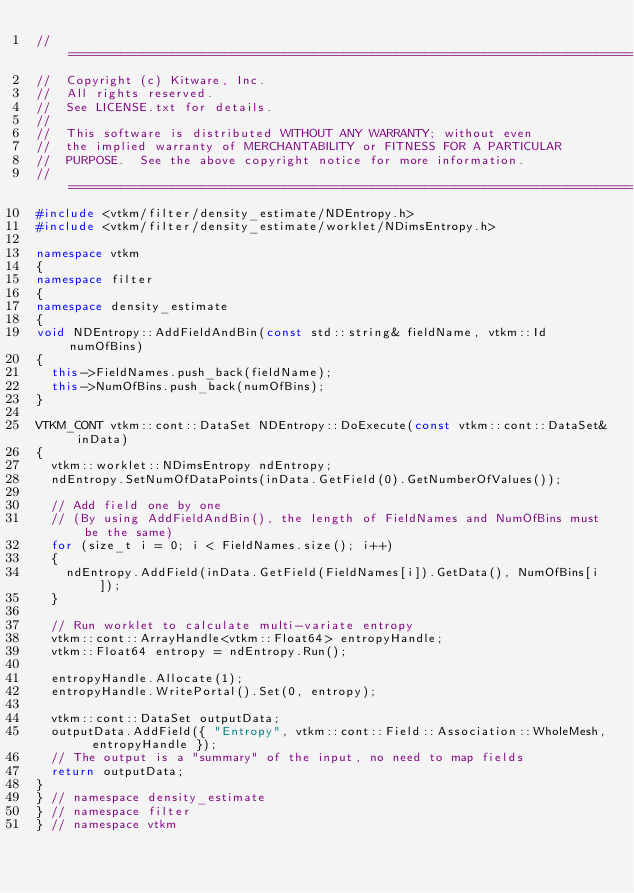Convert code to text. <code><loc_0><loc_0><loc_500><loc_500><_C++_>//============================================================================
//  Copyright (c) Kitware, Inc.
//  All rights reserved.
//  See LICENSE.txt for details.
//
//  This software is distributed WITHOUT ANY WARRANTY; without even
//  the implied warranty of MERCHANTABILITY or FITNESS FOR A PARTICULAR
//  PURPOSE.  See the above copyright notice for more information.
//============================================================================
#include <vtkm/filter/density_estimate/NDEntropy.h>
#include <vtkm/filter/density_estimate/worklet/NDimsEntropy.h>

namespace vtkm
{
namespace filter
{
namespace density_estimate
{
void NDEntropy::AddFieldAndBin(const std::string& fieldName, vtkm::Id numOfBins)
{
  this->FieldNames.push_back(fieldName);
  this->NumOfBins.push_back(numOfBins);
}

VTKM_CONT vtkm::cont::DataSet NDEntropy::DoExecute(const vtkm::cont::DataSet& inData)
{
  vtkm::worklet::NDimsEntropy ndEntropy;
  ndEntropy.SetNumOfDataPoints(inData.GetField(0).GetNumberOfValues());

  // Add field one by one
  // (By using AddFieldAndBin(), the length of FieldNames and NumOfBins must be the same)
  for (size_t i = 0; i < FieldNames.size(); i++)
  {
    ndEntropy.AddField(inData.GetField(FieldNames[i]).GetData(), NumOfBins[i]);
  }

  // Run worklet to calculate multi-variate entropy
  vtkm::cont::ArrayHandle<vtkm::Float64> entropyHandle;
  vtkm::Float64 entropy = ndEntropy.Run();

  entropyHandle.Allocate(1);
  entropyHandle.WritePortal().Set(0, entropy);

  vtkm::cont::DataSet outputData;
  outputData.AddField({ "Entropy", vtkm::cont::Field::Association::WholeMesh, entropyHandle });
  // The output is a "summary" of the input, no need to map fields
  return outputData;
}
} // namespace density_estimate
} // namespace filter
} // namespace vtkm
</code> 